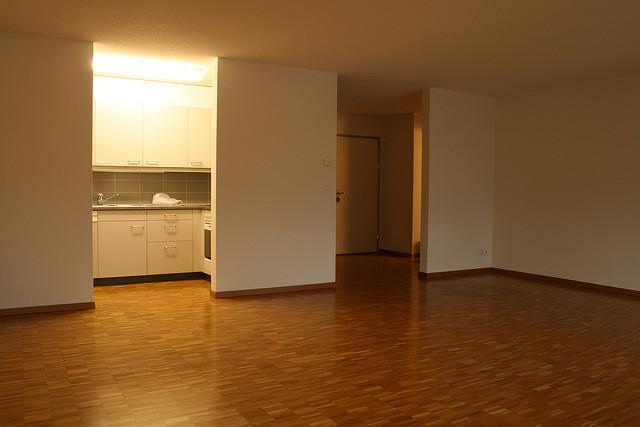How many doorways are pictured in the room?
Give a very brief answer. 2. How many electrical outlets are on the walls?
Give a very brief answer. 1. 